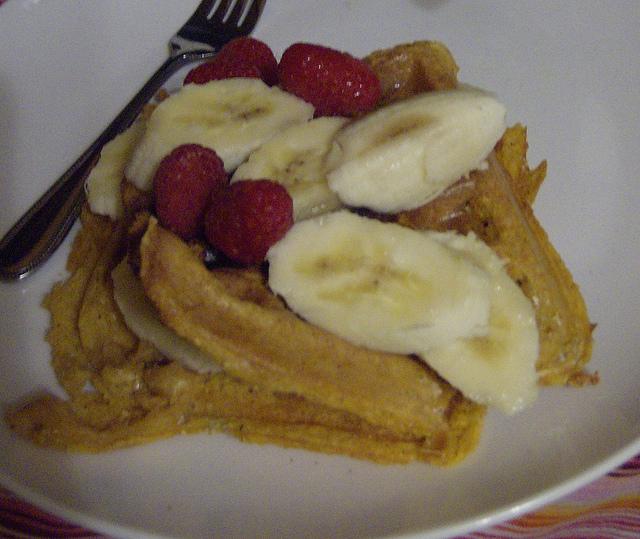Is this a healthy dinner?
Answer briefly. No. What berries are on the pie?
Quick response, please. Raspberries. Is there any tuna on this plate?
Short answer required. No. What is the red stuff on the cake?
Quick response, please. Strawberries. Are multiple types of berries on the food?
Write a very short answer. No. Is this dessert high calorie?
Short answer required. Yes. Are these pancakes?
Keep it brief. No. What kind of desert is this?
Answer briefly. Fruit. What fruit is on this dessert?
Give a very brief answer. Banana. What fruit is in the picture?
Quick response, please. Banana. How many cherries are on top?
Quick response, please. 0. What is the red stuff on the plate?
Be succinct. Raspberries. 